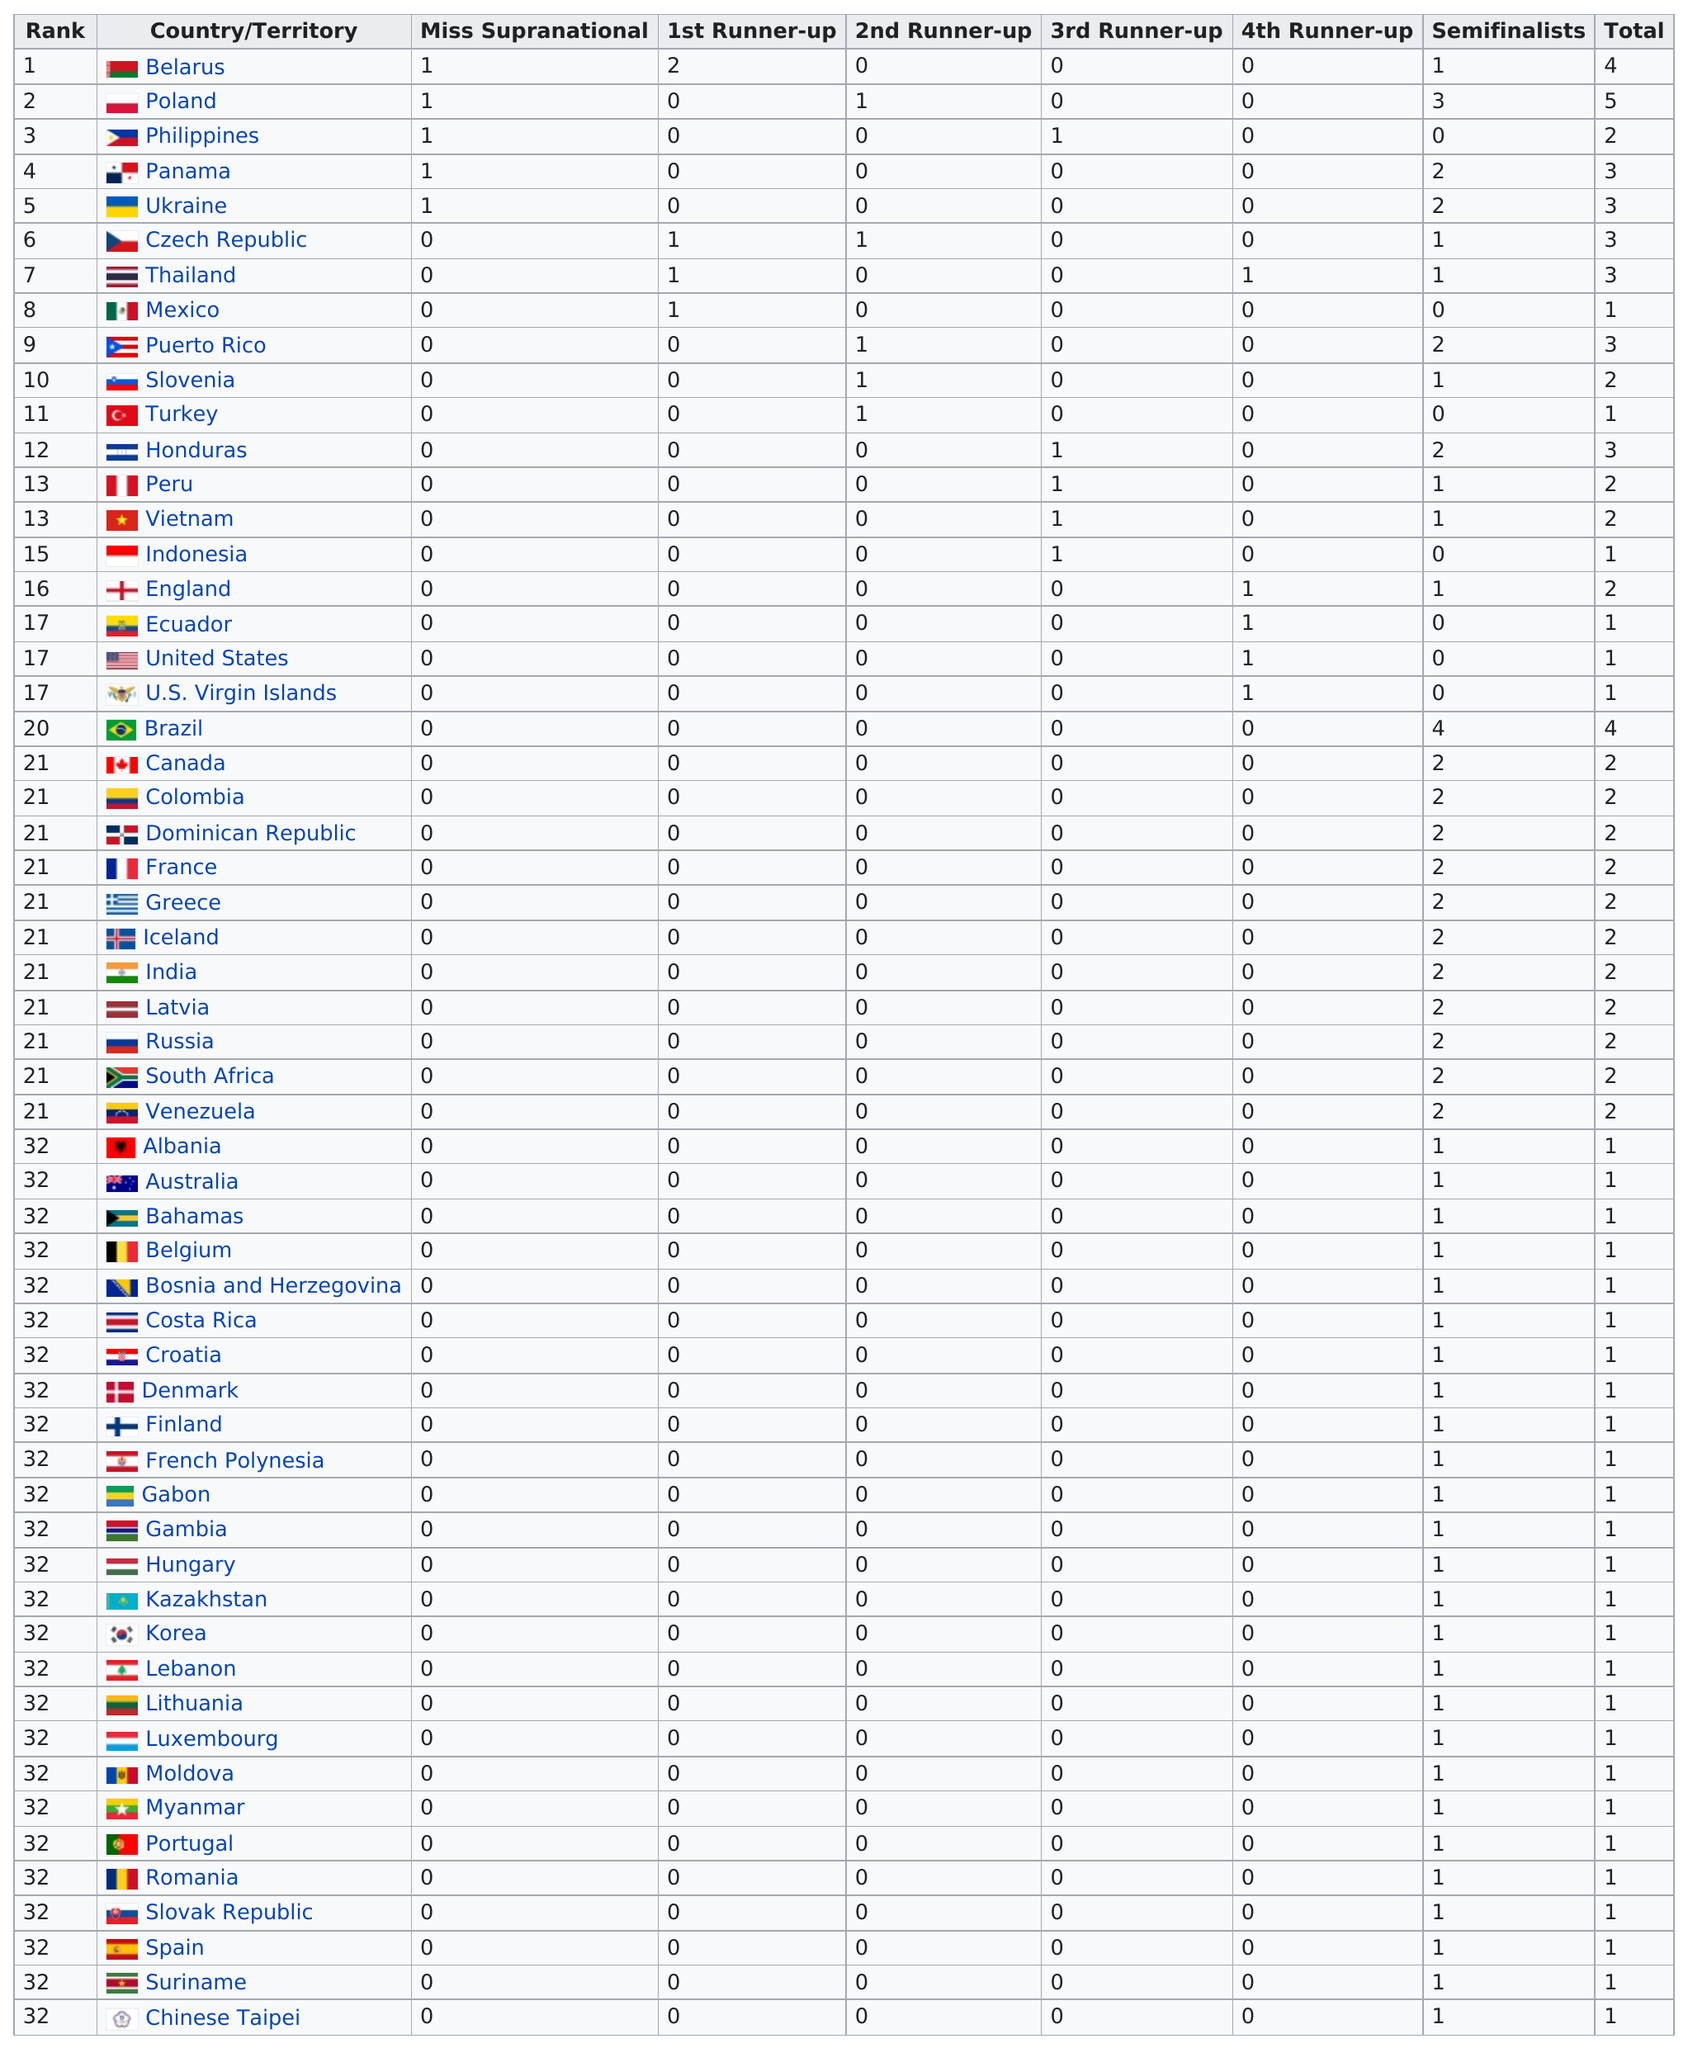Highlight a few significant elements in this photo. Slovenia is above Turkey in the country ranking. The number of misses from Puerto Rico is zero. Belarus has been the first runner-up two times. The United States has achieved victory only once, and in that instance, they placed fourth. It is official, Belarus is the first country to have a 1st runner-up of 2. 